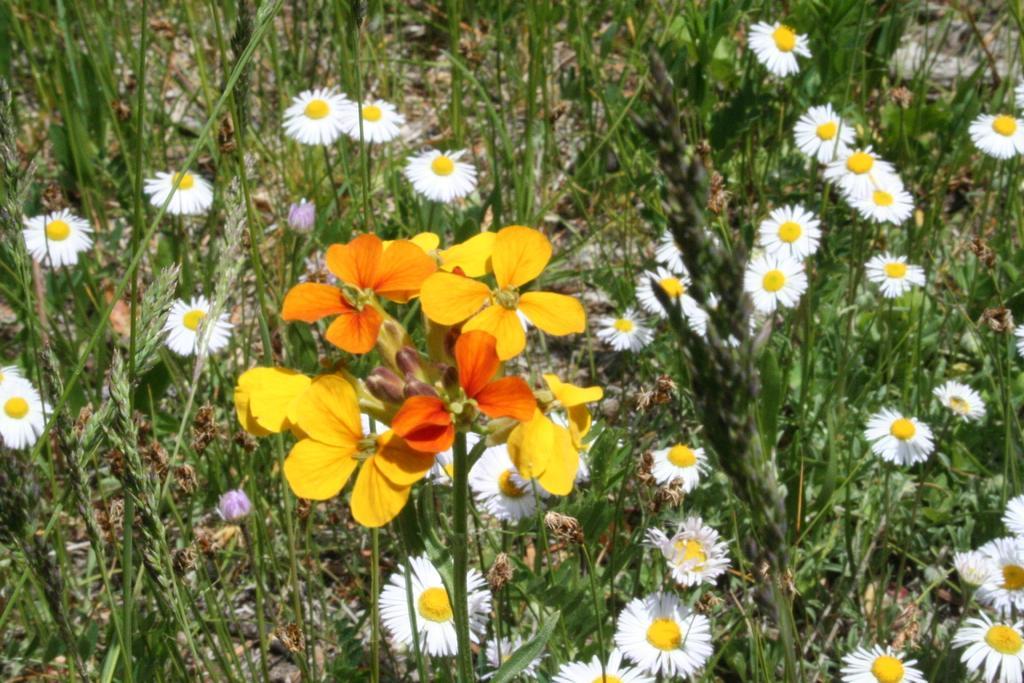Describe this image in one or two sentences. In the image we can see some flowers and plants. 